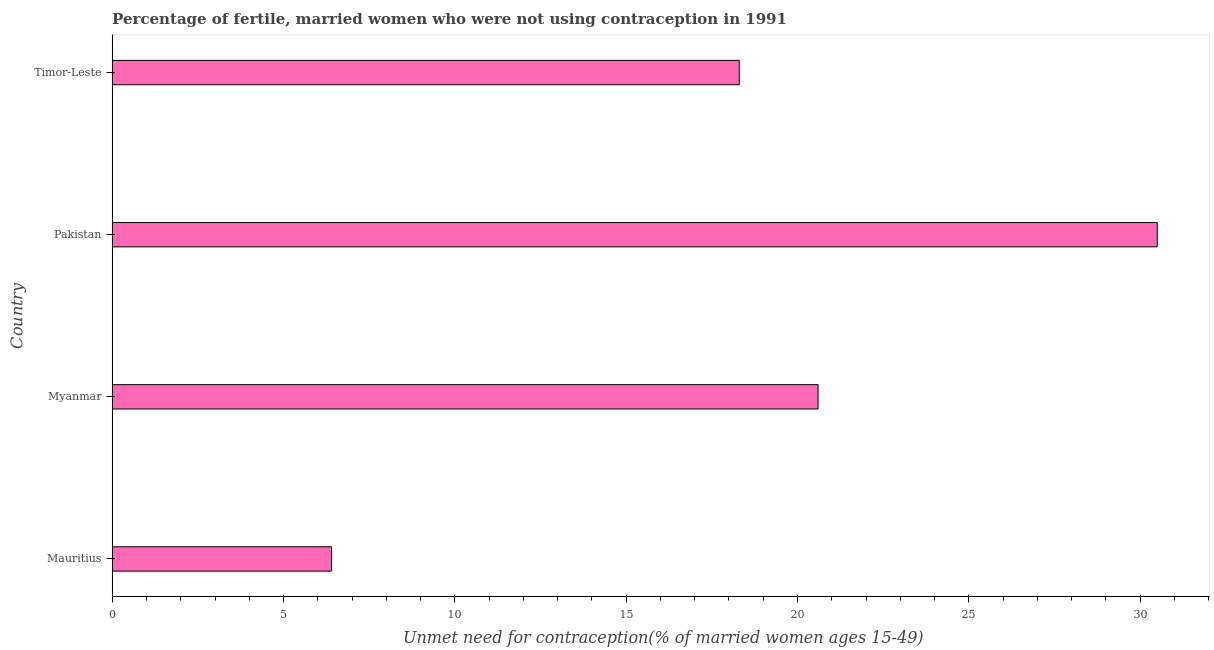What is the title of the graph?
Your response must be concise. Percentage of fertile, married women who were not using contraception in 1991. What is the label or title of the X-axis?
Offer a very short reply.  Unmet need for contraception(% of married women ages 15-49). What is the label or title of the Y-axis?
Ensure brevity in your answer.  Country. What is the number of married women who are not using contraception in Myanmar?
Keep it short and to the point. 20.6. Across all countries, what is the maximum number of married women who are not using contraception?
Your response must be concise. 30.5. In which country was the number of married women who are not using contraception minimum?
Give a very brief answer. Mauritius. What is the sum of the number of married women who are not using contraception?
Ensure brevity in your answer.  75.8. What is the average number of married women who are not using contraception per country?
Your response must be concise. 18.95. What is the median number of married women who are not using contraception?
Your answer should be very brief. 19.45. What is the ratio of the number of married women who are not using contraception in Pakistan to that in Timor-Leste?
Your response must be concise. 1.67. Is the number of married women who are not using contraception in Pakistan less than that in Timor-Leste?
Your response must be concise. No. What is the difference between the highest and the lowest number of married women who are not using contraception?
Provide a short and direct response. 24.1. Are all the bars in the graph horizontal?
Provide a short and direct response. Yes. How many countries are there in the graph?
Make the answer very short. 4. What is the difference between two consecutive major ticks on the X-axis?
Provide a succinct answer. 5. What is the  Unmet need for contraception(% of married women ages 15-49) of Mauritius?
Keep it short and to the point. 6.4. What is the  Unmet need for contraception(% of married women ages 15-49) in Myanmar?
Provide a short and direct response. 20.6. What is the  Unmet need for contraception(% of married women ages 15-49) in Pakistan?
Make the answer very short. 30.5. What is the difference between the  Unmet need for contraception(% of married women ages 15-49) in Mauritius and Myanmar?
Provide a short and direct response. -14.2. What is the difference between the  Unmet need for contraception(% of married women ages 15-49) in Mauritius and Pakistan?
Your answer should be very brief. -24.1. What is the difference between the  Unmet need for contraception(% of married women ages 15-49) in Mauritius and Timor-Leste?
Your response must be concise. -11.9. What is the ratio of the  Unmet need for contraception(% of married women ages 15-49) in Mauritius to that in Myanmar?
Give a very brief answer. 0.31. What is the ratio of the  Unmet need for contraception(% of married women ages 15-49) in Mauritius to that in Pakistan?
Your answer should be very brief. 0.21. What is the ratio of the  Unmet need for contraception(% of married women ages 15-49) in Myanmar to that in Pakistan?
Make the answer very short. 0.68. What is the ratio of the  Unmet need for contraception(% of married women ages 15-49) in Myanmar to that in Timor-Leste?
Make the answer very short. 1.13. What is the ratio of the  Unmet need for contraception(% of married women ages 15-49) in Pakistan to that in Timor-Leste?
Your answer should be very brief. 1.67. 